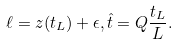<formula> <loc_0><loc_0><loc_500><loc_500>\ell = z ( t _ { L } ) + \epsilon , \hat { t } = Q \frac { t _ { L } } { L } .</formula> 